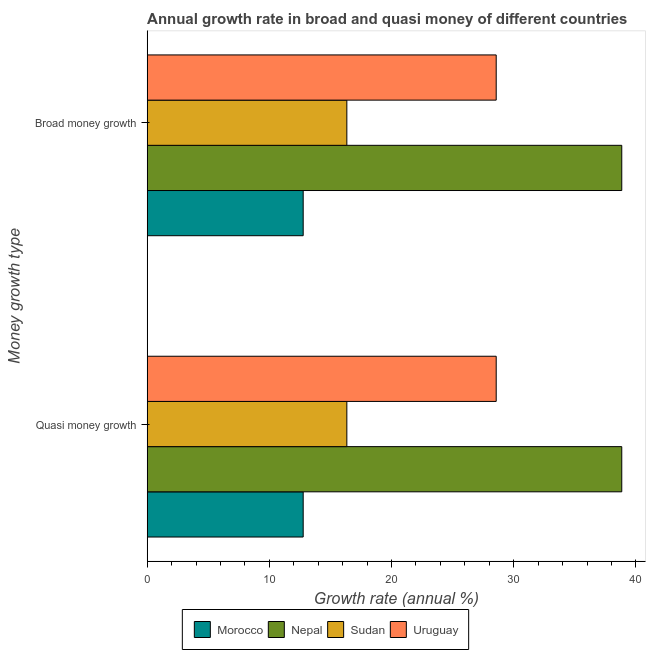How many different coloured bars are there?
Ensure brevity in your answer.  4. How many groups of bars are there?
Your response must be concise. 2. Are the number of bars per tick equal to the number of legend labels?
Keep it short and to the point. Yes. How many bars are there on the 2nd tick from the bottom?
Your response must be concise. 4. What is the label of the 2nd group of bars from the top?
Your response must be concise. Quasi money growth. What is the annual growth rate in quasi money in Sudan?
Make the answer very short. 16.34. Across all countries, what is the maximum annual growth rate in quasi money?
Offer a terse response. 38.84. Across all countries, what is the minimum annual growth rate in broad money?
Offer a terse response. 12.77. In which country was the annual growth rate in broad money maximum?
Offer a very short reply. Nepal. In which country was the annual growth rate in broad money minimum?
Your answer should be compact. Morocco. What is the total annual growth rate in quasi money in the graph?
Make the answer very short. 96.52. What is the difference between the annual growth rate in broad money in Sudan and that in Morocco?
Provide a short and direct response. 3.57. What is the difference between the annual growth rate in broad money in Morocco and the annual growth rate in quasi money in Uruguay?
Keep it short and to the point. -15.8. What is the average annual growth rate in broad money per country?
Provide a succinct answer. 24.13. What is the difference between the annual growth rate in broad money and annual growth rate in quasi money in Sudan?
Ensure brevity in your answer.  0. What is the ratio of the annual growth rate in broad money in Uruguay to that in Nepal?
Offer a very short reply. 0.74. Is the annual growth rate in quasi money in Uruguay less than that in Sudan?
Provide a succinct answer. No. What does the 4th bar from the top in Broad money growth represents?
Offer a very short reply. Morocco. What does the 3rd bar from the bottom in Quasi money growth represents?
Your response must be concise. Sudan. Are all the bars in the graph horizontal?
Provide a succinct answer. Yes. How many countries are there in the graph?
Keep it short and to the point. 4. What is the difference between two consecutive major ticks on the X-axis?
Make the answer very short. 10. Where does the legend appear in the graph?
Your answer should be compact. Bottom center. How are the legend labels stacked?
Give a very brief answer. Horizontal. What is the title of the graph?
Ensure brevity in your answer.  Annual growth rate in broad and quasi money of different countries. Does "Central African Republic" appear as one of the legend labels in the graph?
Offer a very short reply. No. What is the label or title of the X-axis?
Offer a terse response. Growth rate (annual %). What is the label or title of the Y-axis?
Provide a succinct answer. Money growth type. What is the Growth rate (annual %) in Morocco in Quasi money growth?
Keep it short and to the point. 12.77. What is the Growth rate (annual %) in Nepal in Quasi money growth?
Ensure brevity in your answer.  38.84. What is the Growth rate (annual %) of Sudan in Quasi money growth?
Give a very brief answer. 16.34. What is the Growth rate (annual %) of Uruguay in Quasi money growth?
Your answer should be very brief. 28.57. What is the Growth rate (annual %) in Morocco in Broad money growth?
Keep it short and to the point. 12.77. What is the Growth rate (annual %) of Nepal in Broad money growth?
Make the answer very short. 38.84. What is the Growth rate (annual %) in Sudan in Broad money growth?
Offer a very short reply. 16.34. What is the Growth rate (annual %) of Uruguay in Broad money growth?
Make the answer very short. 28.57. Across all Money growth type, what is the maximum Growth rate (annual %) of Morocco?
Ensure brevity in your answer.  12.77. Across all Money growth type, what is the maximum Growth rate (annual %) of Nepal?
Provide a succinct answer. 38.84. Across all Money growth type, what is the maximum Growth rate (annual %) of Sudan?
Offer a very short reply. 16.34. Across all Money growth type, what is the maximum Growth rate (annual %) in Uruguay?
Ensure brevity in your answer.  28.57. Across all Money growth type, what is the minimum Growth rate (annual %) of Morocco?
Provide a succinct answer. 12.77. Across all Money growth type, what is the minimum Growth rate (annual %) in Nepal?
Offer a very short reply. 38.84. Across all Money growth type, what is the minimum Growth rate (annual %) in Sudan?
Provide a short and direct response. 16.34. Across all Money growth type, what is the minimum Growth rate (annual %) of Uruguay?
Your answer should be very brief. 28.57. What is the total Growth rate (annual %) of Morocco in the graph?
Offer a very short reply. 25.54. What is the total Growth rate (annual %) in Nepal in the graph?
Ensure brevity in your answer.  77.68. What is the total Growth rate (annual %) of Sudan in the graph?
Your answer should be very brief. 32.68. What is the total Growth rate (annual %) in Uruguay in the graph?
Keep it short and to the point. 57.13. What is the difference between the Growth rate (annual %) in Nepal in Quasi money growth and that in Broad money growth?
Ensure brevity in your answer.  0. What is the difference between the Growth rate (annual %) of Uruguay in Quasi money growth and that in Broad money growth?
Give a very brief answer. 0. What is the difference between the Growth rate (annual %) of Morocco in Quasi money growth and the Growth rate (annual %) of Nepal in Broad money growth?
Keep it short and to the point. -26.07. What is the difference between the Growth rate (annual %) of Morocco in Quasi money growth and the Growth rate (annual %) of Sudan in Broad money growth?
Provide a short and direct response. -3.57. What is the difference between the Growth rate (annual %) of Morocco in Quasi money growth and the Growth rate (annual %) of Uruguay in Broad money growth?
Keep it short and to the point. -15.8. What is the difference between the Growth rate (annual %) of Nepal in Quasi money growth and the Growth rate (annual %) of Sudan in Broad money growth?
Your answer should be compact. 22.5. What is the difference between the Growth rate (annual %) of Nepal in Quasi money growth and the Growth rate (annual %) of Uruguay in Broad money growth?
Provide a succinct answer. 10.28. What is the difference between the Growth rate (annual %) in Sudan in Quasi money growth and the Growth rate (annual %) in Uruguay in Broad money growth?
Make the answer very short. -12.22. What is the average Growth rate (annual %) of Morocco per Money growth type?
Offer a very short reply. 12.77. What is the average Growth rate (annual %) in Nepal per Money growth type?
Provide a succinct answer. 38.84. What is the average Growth rate (annual %) of Sudan per Money growth type?
Give a very brief answer. 16.34. What is the average Growth rate (annual %) of Uruguay per Money growth type?
Provide a short and direct response. 28.57. What is the difference between the Growth rate (annual %) in Morocco and Growth rate (annual %) in Nepal in Quasi money growth?
Your answer should be very brief. -26.07. What is the difference between the Growth rate (annual %) in Morocco and Growth rate (annual %) in Sudan in Quasi money growth?
Your response must be concise. -3.57. What is the difference between the Growth rate (annual %) of Morocco and Growth rate (annual %) of Uruguay in Quasi money growth?
Keep it short and to the point. -15.8. What is the difference between the Growth rate (annual %) of Nepal and Growth rate (annual %) of Sudan in Quasi money growth?
Your answer should be very brief. 22.5. What is the difference between the Growth rate (annual %) of Nepal and Growth rate (annual %) of Uruguay in Quasi money growth?
Keep it short and to the point. 10.28. What is the difference between the Growth rate (annual %) of Sudan and Growth rate (annual %) of Uruguay in Quasi money growth?
Provide a short and direct response. -12.22. What is the difference between the Growth rate (annual %) of Morocco and Growth rate (annual %) of Nepal in Broad money growth?
Give a very brief answer. -26.07. What is the difference between the Growth rate (annual %) in Morocco and Growth rate (annual %) in Sudan in Broad money growth?
Make the answer very short. -3.57. What is the difference between the Growth rate (annual %) of Morocco and Growth rate (annual %) of Uruguay in Broad money growth?
Your answer should be very brief. -15.8. What is the difference between the Growth rate (annual %) in Nepal and Growth rate (annual %) in Sudan in Broad money growth?
Ensure brevity in your answer.  22.5. What is the difference between the Growth rate (annual %) in Nepal and Growth rate (annual %) in Uruguay in Broad money growth?
Give a very brief answer. 10.28. What is the difference between the Growth rate (annual %) in Sudan and Growth rate (annual %) in Uruguay in Broad money growth?
Provide a short and direct response. -12.22. What is the ratio of the Growth rate (annual %) of Sudan in Quasi money growth to that in Broad money growth?
Your response must be concise. 1. What is the difference between the highest and the second highest Growth rate (annual %) in Nepal?
Offer a very short reply. 0. What is the difference between the highest and the second highest Growth rate (annual %) in Sudan?
Make the answer very short. 0. What is the difference between the highest and the second highest Growth rate (annual %) of Uruguay?
Your answer should be very brief. 0. What is the difference between the highest and the lowest Growth rate (annual %) of Sudan?
Provide a succinct answer. 0. What is the difference between the highest and the lowest Growth rate (annual %) in Uruguay?
Ensure brevity in your answer.  0. 